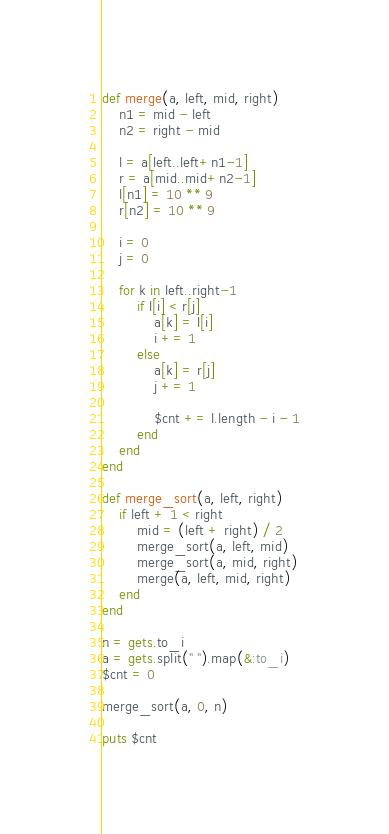Convert code to text. <code><loc_0><loc_0><loc_500><loc_500><_Ruby_>def merge(a, left, mid, right)
	n1 = mid - left
	n2 = right - mid
	
	l = a[left..left+n1-1]
	r = a[mid..mid+n2-1]
	l[n1] = 10 ** 9
	r[n2] = 10 ** 9

	i = 0
	j = 0
	
	for k in left..right-1
		if l[i] < r[j]
			a[k] = l[i]
			i += 1
		else
			a[k] = r[j]
			j += 1
			
			$cnt += l.length - i - 1
		end
	end
end

def merge_sort(a, left, right)
	if left + 1 < right
		mid = (left + right) / 2
		merge_sort(a, left, mid)
		merge_sort(a, mid, right)
		merge(a, left, mid, right)
	end
end

n = gets.to_i
a = gets.split(" ").map(&:to_i)
$cnt = 0

merge_sort(a, 0, n)

puts $cnt</code> 